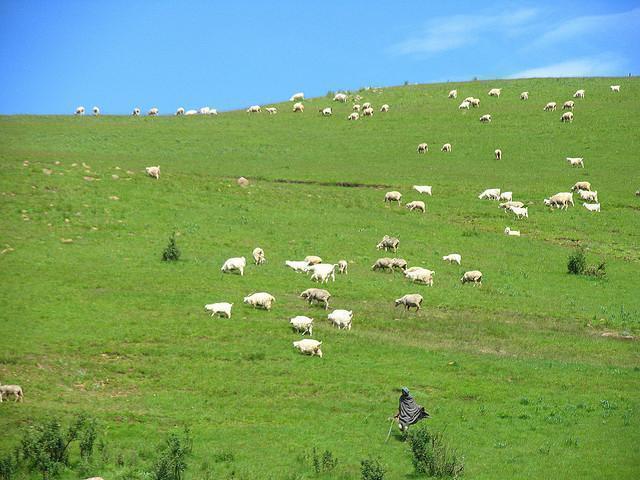What might the man be attempting to do with the animals?
Answer the question by selecting the correct answer among the 4 following choices and explain your choice with a short sentence. The answer should be formatted with the following format: `Answer: choice
Rationale: rationale.`
Options: Herd them, sheer them, hunt them, ride them. Answer: herd them.
Rationale: He is trying to gather them all to move them to another spot. 